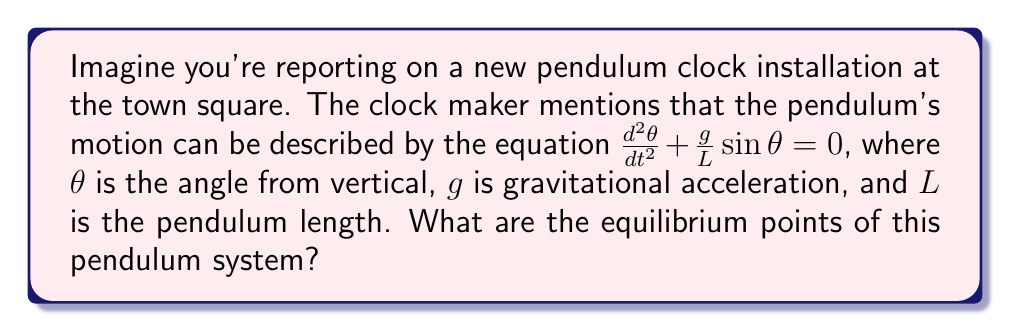What is the answer to this math problem? To find the equilibrium points, we need to follow these steps:

1. Recall that equilibrium points occur when there is no change in the system over time. This means both velocity and acceleration are zero.

2. We can rewrite the second-order differential equation as a system of first-order equations:
   $$\frac{d\theta}{dt} = \omega$$
   $$\frac{d\omega}{dt} = -\frac{g}{L}\sin\theta$$

3. At equilibrium points, both derivatives are zero:
   $$\frac{d\theta}{dt} = \omega = 0$$
   $$\frac{d\omega}{dt} = -\frac{g}{L}\sin\theta = 0$$

4. From the second equation, we can see that $\sin\theta = 0$ (since $g$ and $L$ are non-zero constants).

5. The solutions to $\sin\theta = 0$ are:
   $$\theta = 0, \pi, 2\pi, 3\pi, \ldots$$
   Or more generally: $\theta = n\pi$, where $n$ is any integer.

6. However, since $\theta$ represents an angle, we only need to consider the unique positions within one full rotation. Therefore, the two distinct equilibrium points are:
   $$\theta = 0$$ (pendulum hanging straight down)
   $$\theta = \pi$$ (pendulum pointing straight up)
Answer: $\theta = 0$ and $\theta = \pi$ 